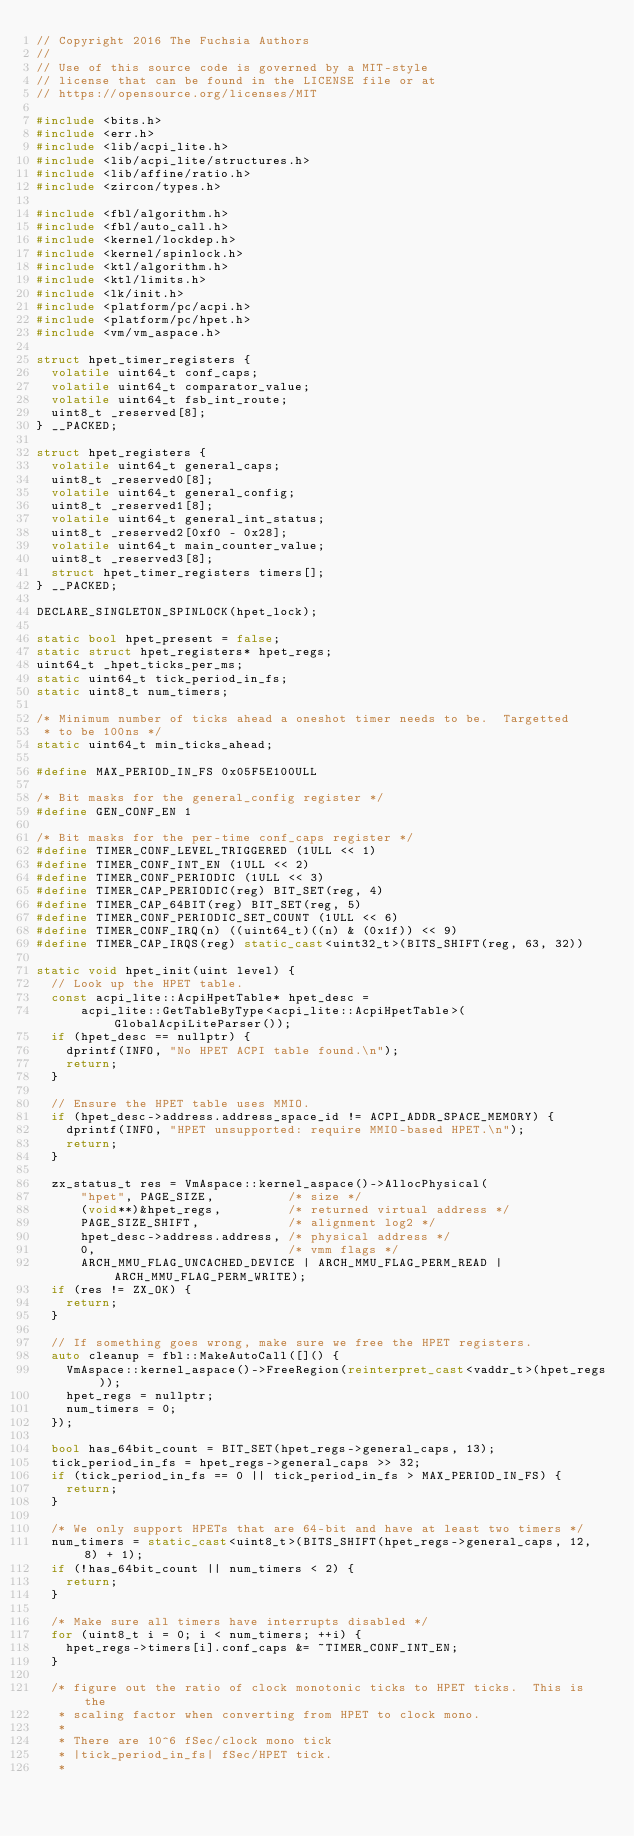<code> <loc_0><loc_0><loc_500><loc_500><_C++_>// Copyright 2016 The Fuchsia Authors
//
// Use of this source code is governed by a MIT-style
// license that can be found in the LICENSE file or at
// https://opensource.org/licenses/MIT

#include <bits.h>
#include <err.h>
#include <lib/acpi_lite.h>
#include <lib/acpi_lite/structures.h>
#include <lib/affine/ratio.h>
#include <zircon/types.h>

#include <fbl/algorithm.h>
#include <fbl/auto_call.h>
#include <kernel/lockdep.h>
#include <kernel/spinlock.h>
#include <ktl/algorithm.h>
#include <ktl/limits.h>
#include <lk/init.h>
#include <platform/pc/acpi.h>
#include <platform/pc/hpet.h>
#include <vm/vm_aspace.h>

struct hpet_timer_registers {
  volatile uint64_t conf_caps;
  volatile uint64_t comparator_value;
  volatile uint64_t fsb_int_route;
  uint8_t _reserved[8];
} __PACKED;

struct hpet_registers {
  volatile uint64_t general_caps;
  uint8_t _reserved0[8];
  volatile uint64_t general_config;
  uint8_t _reserved1[8];
  volatile uint64_t general_int_status;
  uint8_t _reserved2[0xf0 - 0x28];
  volatile uint64_t main_counter_value;
  uint8_t _reserved3[8];
  struct hpet_timer_registers timers[];
} __PACKED;

DECLARE_SINGLETON_SPINLOCK(hpet_lock);

static bool hpet_present = false;
static struct hpet_registers* hpet_regs;
uint64_t _hpet_ticks_per_ms;
static uint64_t tick_period_in_fs;
static uint8_t num_timers;

/* Minimum number of ticks ahead a oneshot timer needs to be.  Targetted
 * to be 100ns */
static uint64_t min_ticks_ahead;

#define MAX_PERIOD_IN_FS 0x05F5E100ULL

/* Bit masks for the general_config register */
#define GEN_CONF_EN 1

/* Bit masks for the per-time conf_caps register */
#define TIMER_CONF_LEVEL_TRIGGERED (1ULL << 1)
#define TIMER_CONF_INT_EN (1ULL << 2)
#define TIMER_CONF_PERIODIC (1ULL << 3)
#define TIMER_CAP_PERIODIC(reg) BIT_SET(reg, 4)
#define TIMER_CAP_64BIT(reg) BIT_SET(reg, 5)
#define TIMER_CONF_PERIODIC_SET_COUNT (1ULL << 6)
#define TIMER_CONF_IRQ(n) ((uint64_t)((n) & (0x1f)) << 9)
#define TIMER_CAP_IRQS(reg) static_cast<uint32_t>(BITS_SHIFT(reg, 63, 32))

static void hpet_init(uint level) {
  // Look up the HPET table.
  const acpi_lite::AcpiHpetTable* hpet_desc =
      acpi_lite::GetTableByType<acpi_lite::AcpiHpetTable>(GlobalAcpiLiteParser());
  if (hpet_desc == nullptr) {
    dprintf(INFO, "No HPET ACPI table found.\n");
    return;
  }

  // Ensure the HPET table uses MMIO.
  if (hpet_desc->address.address_space_id != ACPI_ADDR_SPACE_MEMORY) {
    dprintf(INFO, "HPET unsupported: require MMIO-based HPET.\n");
    return;
  }

  zx_status_t res = VmAspace::kernel_aspace()->AllocPhysical(
      "hpet", PAGE_SIZE,          /* size */
      (void**)&hpet_regs,         /* returned virtual address */
      PAGE_SIZE_SHIFT,            /* alignment log2 */
      hpet_desc->address.address, /* physical address */
      0,                          /* vmm flags */
      ARCH_MMU_FLAG_UNCACHED_DEVICE | ARCH_MMU_FLAG_PERM_READ | ARCH_MMU_FLAG_PERM_WRITE);
  if (res != ZX_OK) {
    return;
  }

  // If something goes wrong, make sure we free the HPET registers.
  auto cleanup = fbl::MakeAutoCall([]() {
    VmAspace::kernel_aspace()->FreeRegion(reinterpret_cast<vaddr_t>(hpet_regs));
    hpet_regs = nullptr;
    num_timers = 0;
  });

  bool has_64bit_count = BIT_SET(hpet_regs->general_caps, 13);
  tick_period_in_fs = hpet_regs->general_caps >> 32;
  if (tick_period_in_fs == 0 || tick_period_in_fs > MAX_PERIOD_IN_FS) {
    return;
  }

  /* We only support HPETs that are 64-bit and have at least two timers */
  num_timers = static_cast<uint8_t>(BITS_SHIFT(hpet_regs->general_caps, 12, 8) + 1);
  if (!has_64bit_count || num_timers < 2) {
    return;
  }

  /* Make sure all timers have interrupts disabled */
  for (uint8_t i = 0; i < num_timers; ++i) {
    hpet_regs->timers[i].conf_caps &= ~TIMER_CONF_INT_EN;
  }

  /* figure out the ratio of clock monotonic ticks to HPET ticks.  This is the
   * scaling factor when converting from HPET to clock mono.
   *
   * There are 10^6 fSec/clock mono tick
   * |tick_period_in_fs| fSec/HPET tick.
   *</code> 